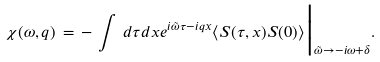Convert formula to latex. <formula><loc_0><loc_0><loc_500><loc_500>\chi ( \omega , q ) \, = \, - \, \int \, d \tau d x e ^ { i \tilde { \omega } \tau - i q x } \langle { S } ( \tau , x ) { S } ( 0 ) \rangle \Big | _ { \tilde { \omega } \rightarrow - i \omega + \delta } .</formula> 